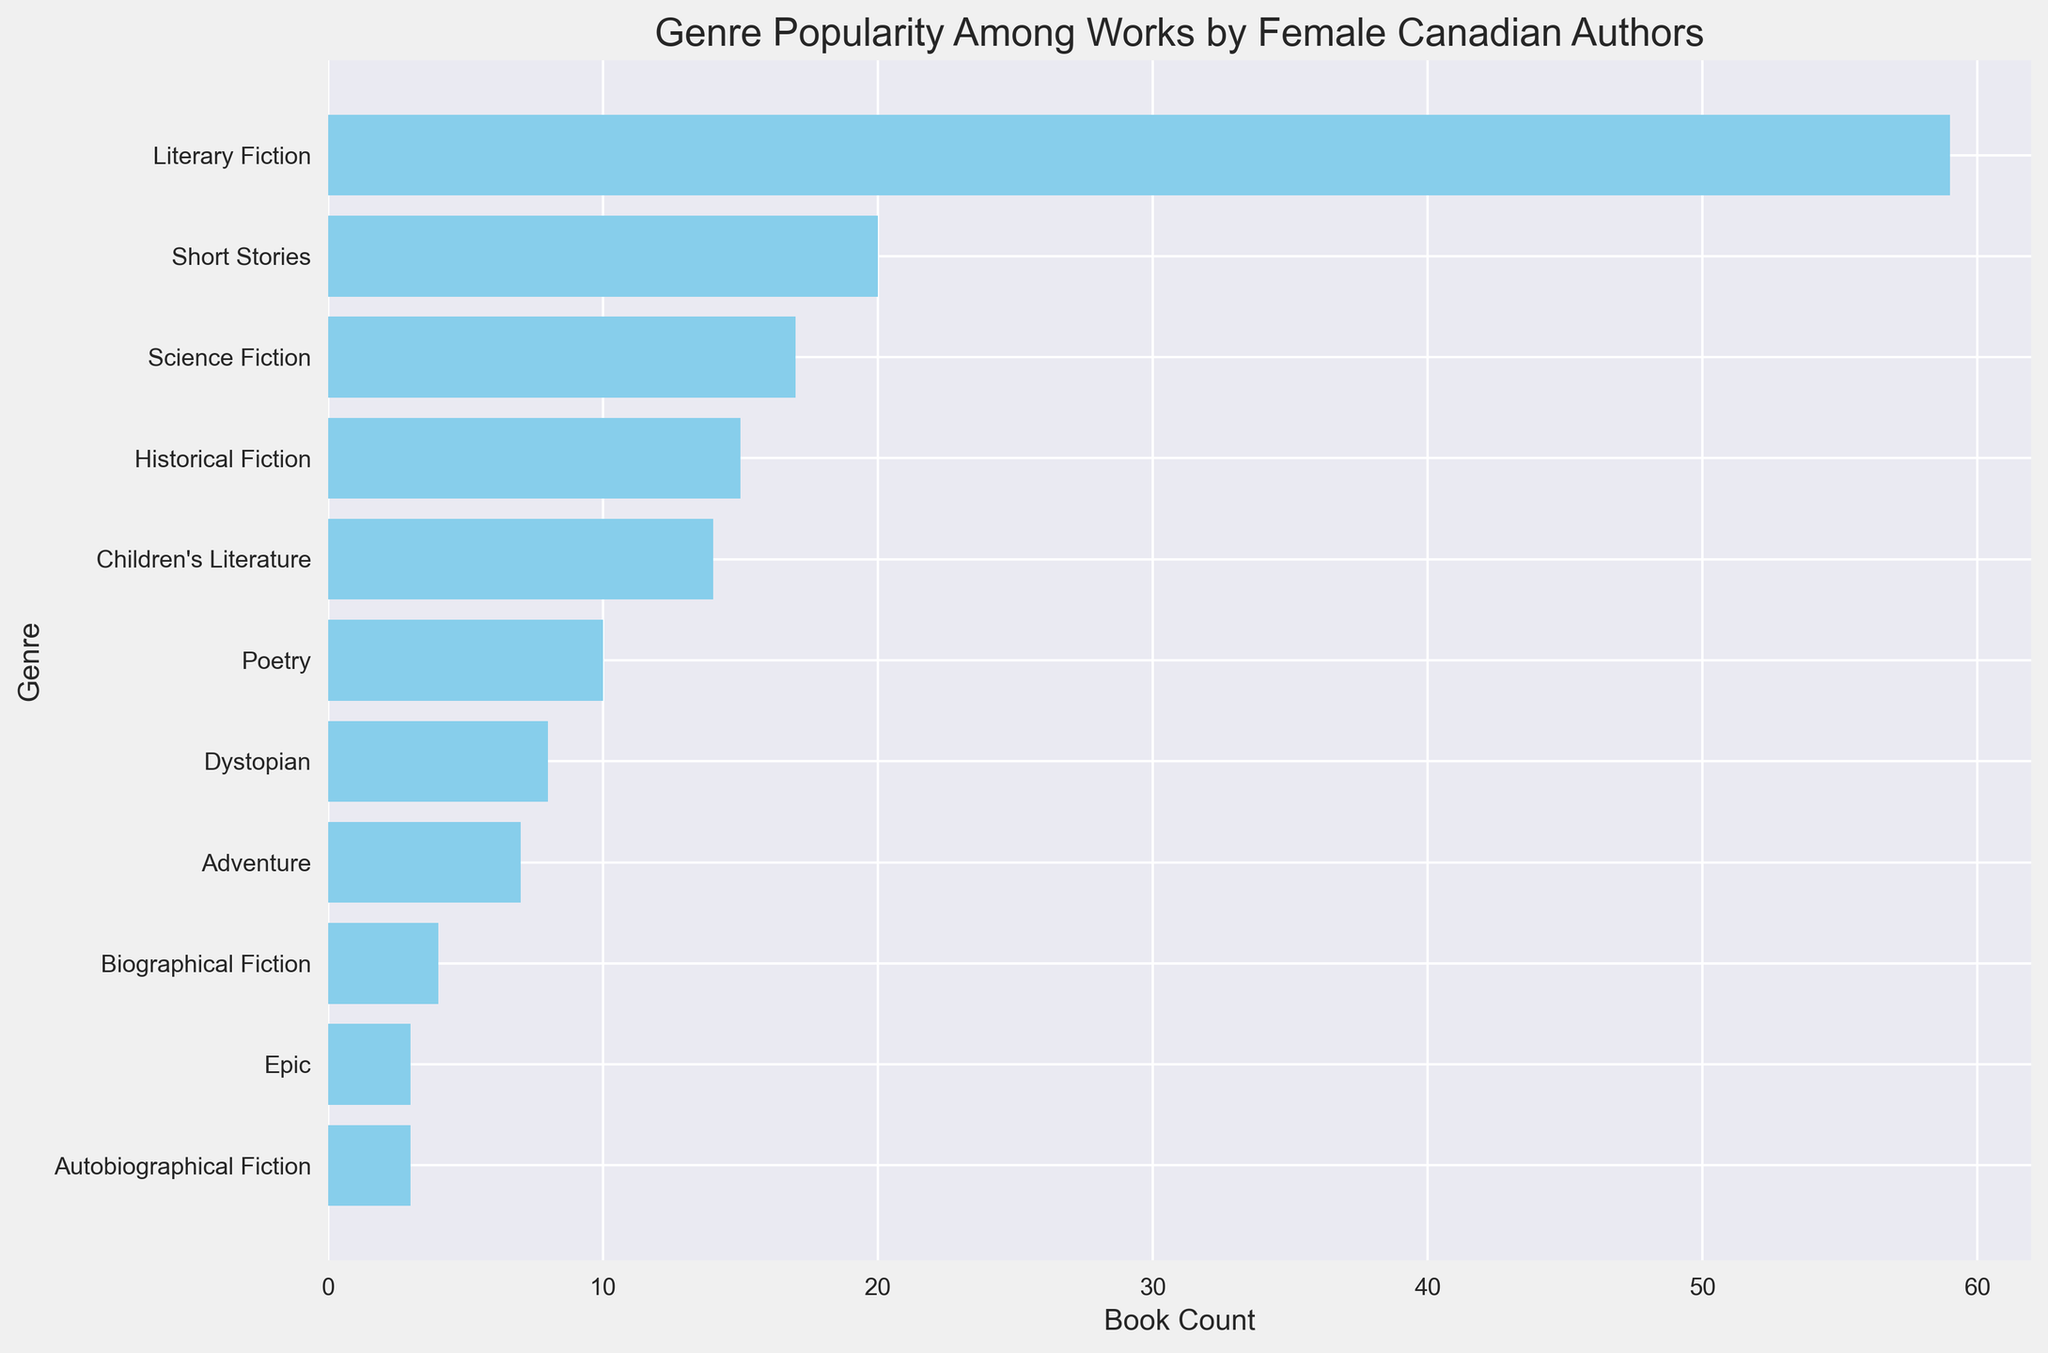What's the most popular genre among works by female Canadian authors? Looking at the bar chart, the genre with the tallest bar represents the most popular genre.
Answer: Literary Fiction Which two genres have the smallest difference in book count, and what is that difference? To find this, compare the difference in book counts between adjacent bars and identify the smallest difference. Historical Fiction (with 6 books) and Adventure (with 7 books) have a difference of 1 book.
Answer: Historical Fiction and Adventure; 1 book How many more books are there in Literary Fiction compared to Short Stories? Find the book count of Literary Fiction and Short Stories from the bar chart, then subtract the book count of Short Stories from Literary Fiction. Literary Fiction has 36 books (sum of all authors) and Short Stories has 20 books. Difference = 36 - 20.
Answer: 16 List all genres that have a book count greater than 10. Identify the bars that extend beyond the 10 books mark on the horizontal axis.
Answer: Literary Fiction, Short Stories, Science Fiction, Children's Literature, Poetry Which genre has the smallest representation and how many books does it have? Locate the shortest bar on the chart, which indicates the genre with the least number of books.
Answer: Historical Fiction (Kim Thúy); 2 books How many genres have a book count of 20 or more? Count the bars that extend to or beyond the 20 books mark on the horizontal axis. Only Short Stories by Alice Munro has 20 or more books.
Answer: 1 Compare the popularity of Dystopian and Science Fiction genres in Margaret Atwood's works. Which is more popular and by how many books? Refer to Margaret Atwood’s bars in the bar chart, check the book counts for Dystopian and Science Fiction, then subtract the book count of Dystopian from Science Fiction. Science Fiction has 12 books while Dystopian has 8 books. Difference = 12 - 8.
Answer: Science Fiction; 4 books Which genre has more books published: Epic or Biographical Fiction? Compare the length of the bars for Epic and Biographical Fiction. Biographical Fiction has 4 books while Epic has 3 books.
Answer: Biographical Fiction 